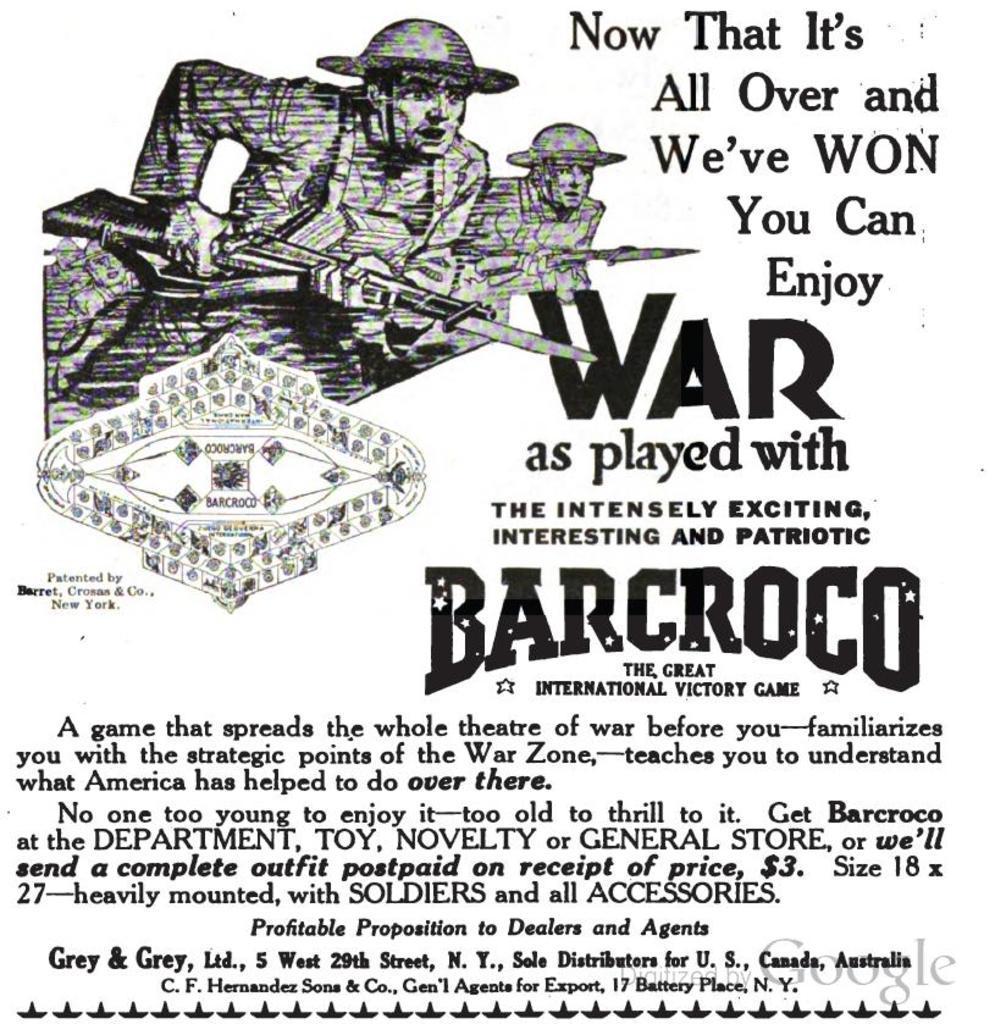Describe this image in one or two sentences. In this picture we can see a paper, on which we can see some text and images like persons. 